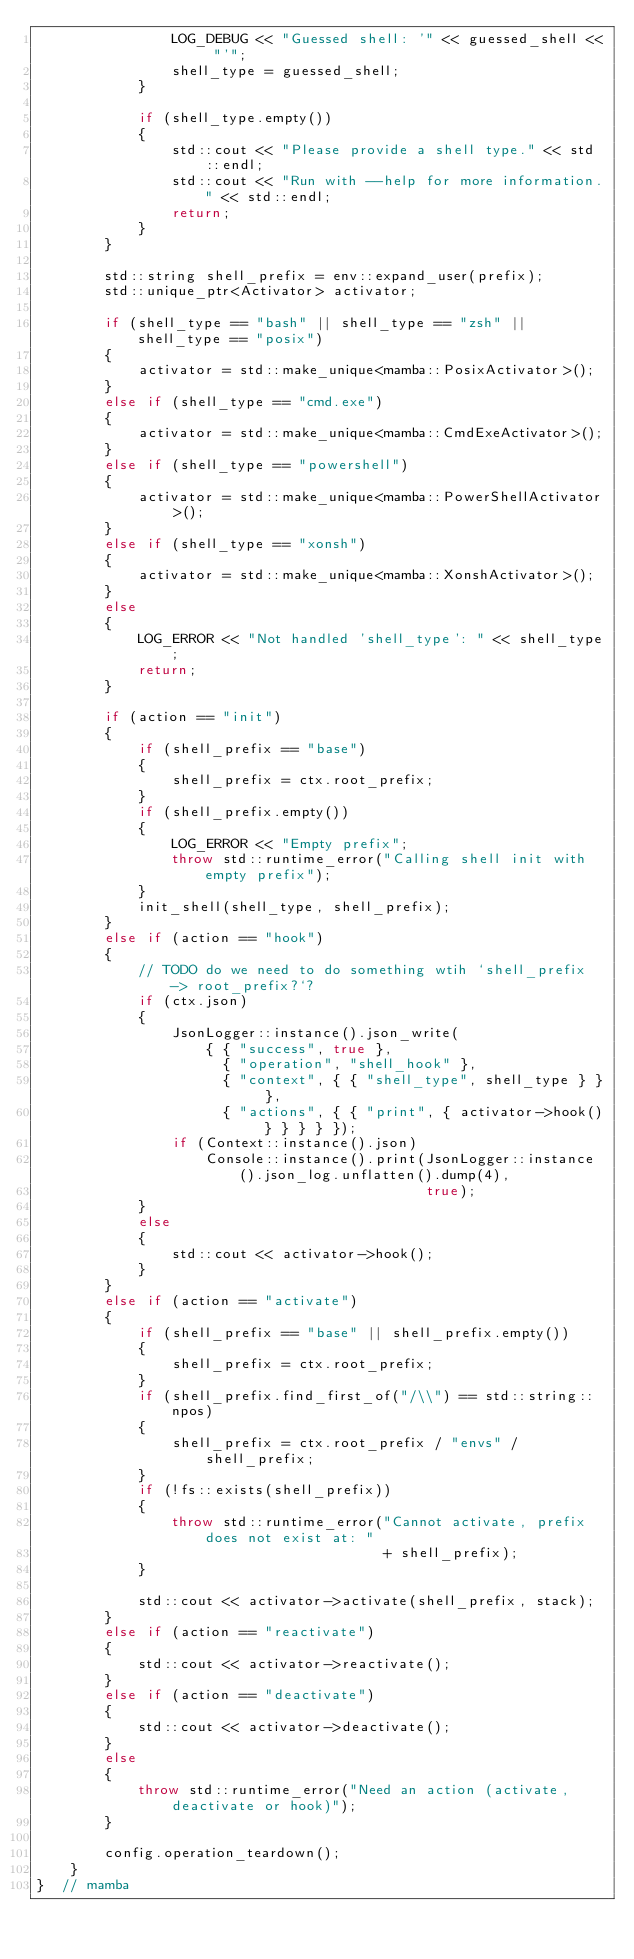Convert code to text. <code><loc_0><loc_0><loc_500><loc_500><_C++_>                LOG_DEBUG << "Guessed shell: '" << guessed_shell << "'";
                shell_type = guessed_shell;
            }

            if (shell_type.empty())
            {
                std::cout << "Please provide a shell type." << std::endl;
                std::cout << "Run with --help for more information." << std::endl;
                return;
            }
        }

        std::string shell_prefix = env::expand_user(prefix);
        std::unique_ptr<Activator> activator;

        if (shell_type == "bash" || shell_type == "zsh" || shell_type == "posix")
        {
            activator = std::make_unique<mamba::PosixActivator>();
        }
        else if (shell_type == "cmd.exe")
        {
            activator = std::make_unique<mamba::CmdExeActivator>();
        }
        else if (shell_type == "powershell")
        {
            activator = std::make_unique<mamba::PowerShellActivator>();
        }
        else if (shell_type == "xonsh")
        {
            activator = std::make_unique<mamba::XonshActivator>();
        }
        else
        {
            LOG_ERROR << "Not handled 'shell_type': " << shell_type;
            return;
        }

        if (action == "init")
        {
            if (shell_prefix == "base")
            {
                shell_prefix = ctx.root_prefix;
            }
            if (shell_prefix.empty())
            {
                LOG_ERROR << "Empty prefix";
                throw std::runtime_error("Calling shell init with empty prefix");
            }
            init_shell(shell_type, shell_prefix);
        }
        else if (action == "hook")
        {
            // TODO do we need to do something wtih `shell_prefix -> root_prefix?`?
            if (ctx.json)
            {
                JsonLogger::instance().json_write(
                    { { "success", true },
                      { "operation", "shell_hook" },
                      { "context", { { "shell_type", shell_type } } },
                      { "actions", { { "print", { activator->hook() } } } } });
                if (Context::instance().json)
                    Console::instance().print(JsonLogger::instance().json_log.unflatten().dump(4),
                                              true);
            }
            else
            {
                std::cout << activator->hook();
            }
        }
        else if (action == "activate")
        {
            if (shell_prefix == "base" || shell_prefix.empty())
            {
                shell_prefix = ctx.root_prefix;
            }
            if (shell_prefix.find_first_of("/\\") == std::string::npos)
            {
                shell_prefix = ctx.root_prefix / "envs" / shell_prefix;
            }
            if (!fs::exists(shell_prefix))
            {
                throw std::runtime_error("Cannot activate, prefix does not exist at: "
                                         + shell_prefix);
            }

            std::cout << activator->activate(shell_prefix, stack);
        }
        else if (action == "reactivate")
        {
            std::cout << activator->reactivate();
        }
        else if (action == "deactivate")
        {
            std::cout << activator->deactivate();
        }
        else
        {
            throw std::runtime_error("Need an action (activate, deactivate or hook)");
        }

        config.operation_teardown();
    }
}  // mamba
</code> 